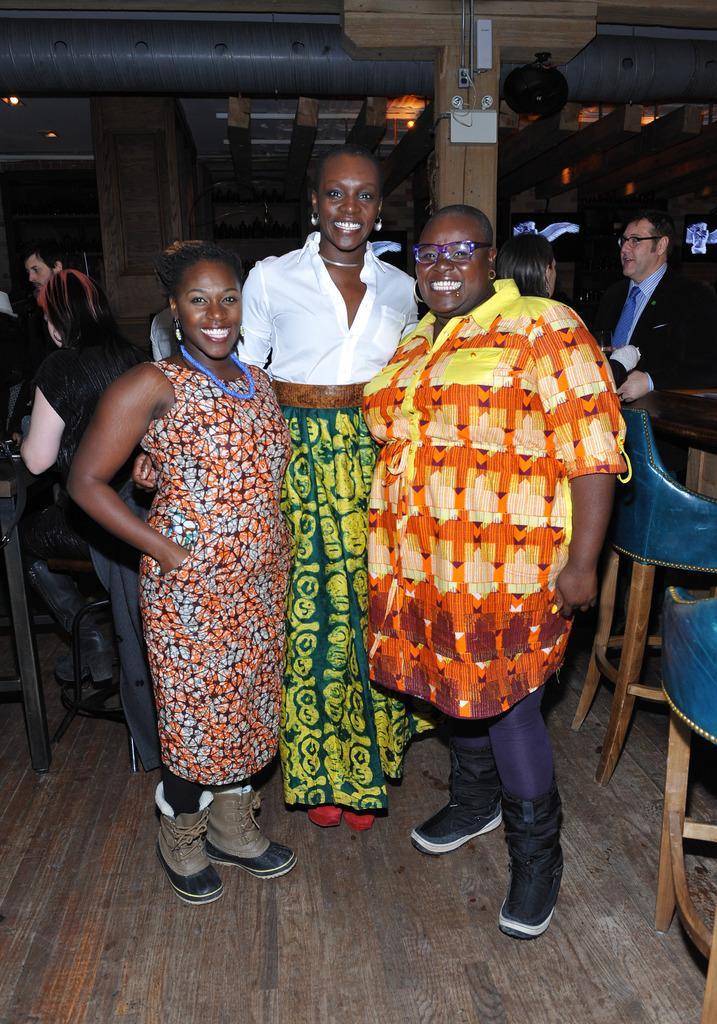Can you describe this image briefly? In front of the image there are three women standing with a smile on their face, behind them there are a few people standing and sitting in chairs. In the background of the image there are switchboards on pillars, pipes and wooden logs on the rooftop and there are neon sign boards on the wall and some other objects. 